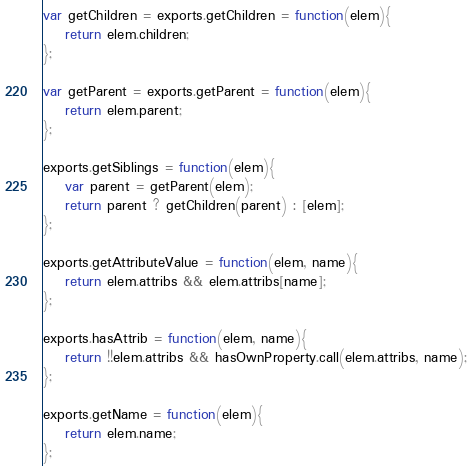Convert code to text. <code><loc_0><loc_0><loc_500><loc_500><_JavaScript_>var getChildren = exports.getChildren = function(elem){
	return elem.children;
};

var getParent = exports.getParent = function(elem){
	return elem.parent;
};

exports.getSiblings = function(elem){
	var parent = getParent(elem);
	return parent ? getChildren(parent) : [elem];
};

exports.getAttributeValue = function(elem, name){
	return elem.attribs && elem.attribs[name];
};

exports.hasAttrib = function(elem, name){
	return !!elem.attribs && hasOwnProperty.call(elem.attribs, name);
};

exports.getName = function(elem){
	return elem.name;
};
</code> 